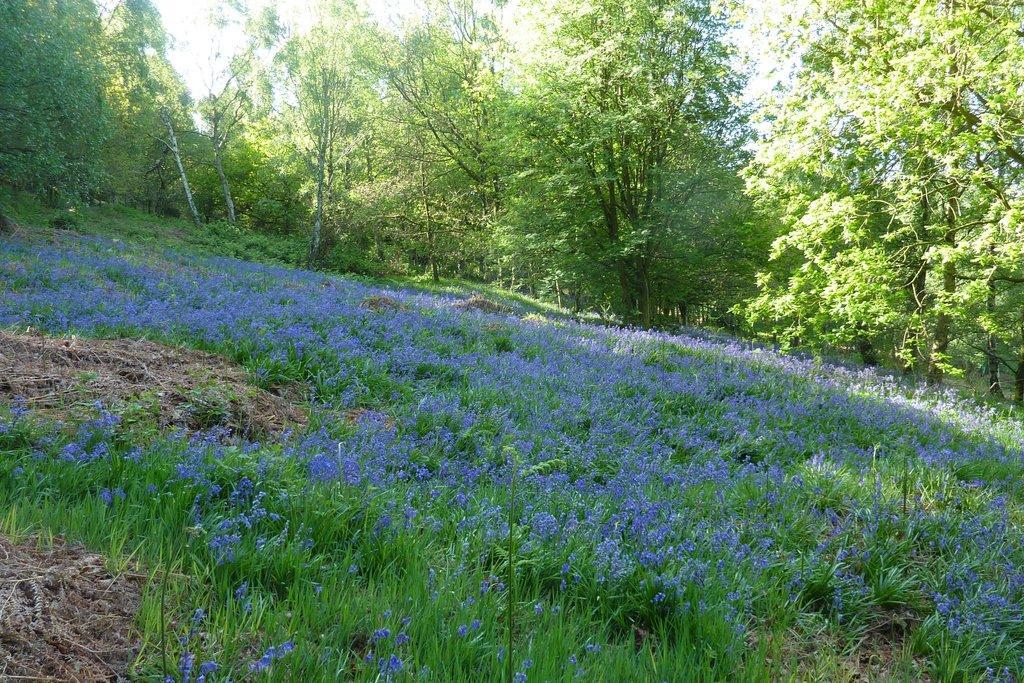Describe this image in one or two sentences. In the picture there is a lot of greenery with grass and trees, there are purple flowers to the grass. 